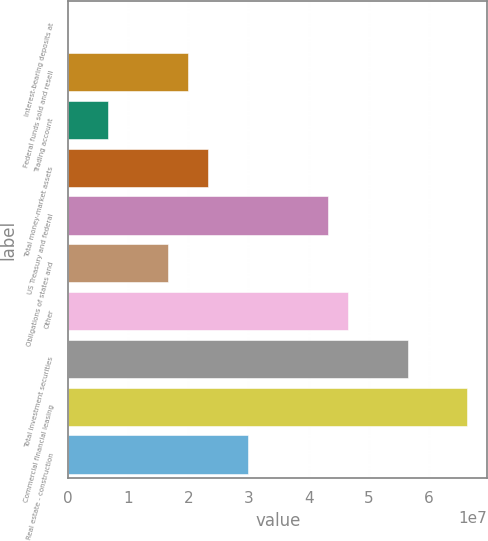Convert chart to OTSL. <chart><loc_0><loc_0><loc_500><loc_500><bar_chart><fcel>Interest-bearing deposits at<fcel>Federal funds sold and resell<fcel>Trading account<fcel>Total money-market assets<fcel>US Treasury and federal<fcel>Obligations of states and<fcel>Other<fcel>Total investment securities<fcel>Commercial financial leasing<fcel>Real estate - construction<nl><fcel>7856<fcel>1.99239e+07<fcel>6.64652e+06<fcel>2.32432e+07<fcel>4.31592e+07<fcel>1.66045e+07<fcel>4.64785e+07<fcel>5.64365e+07<fcel>6.63945e+07<fcel>2.98818e+07<nl></chart> 